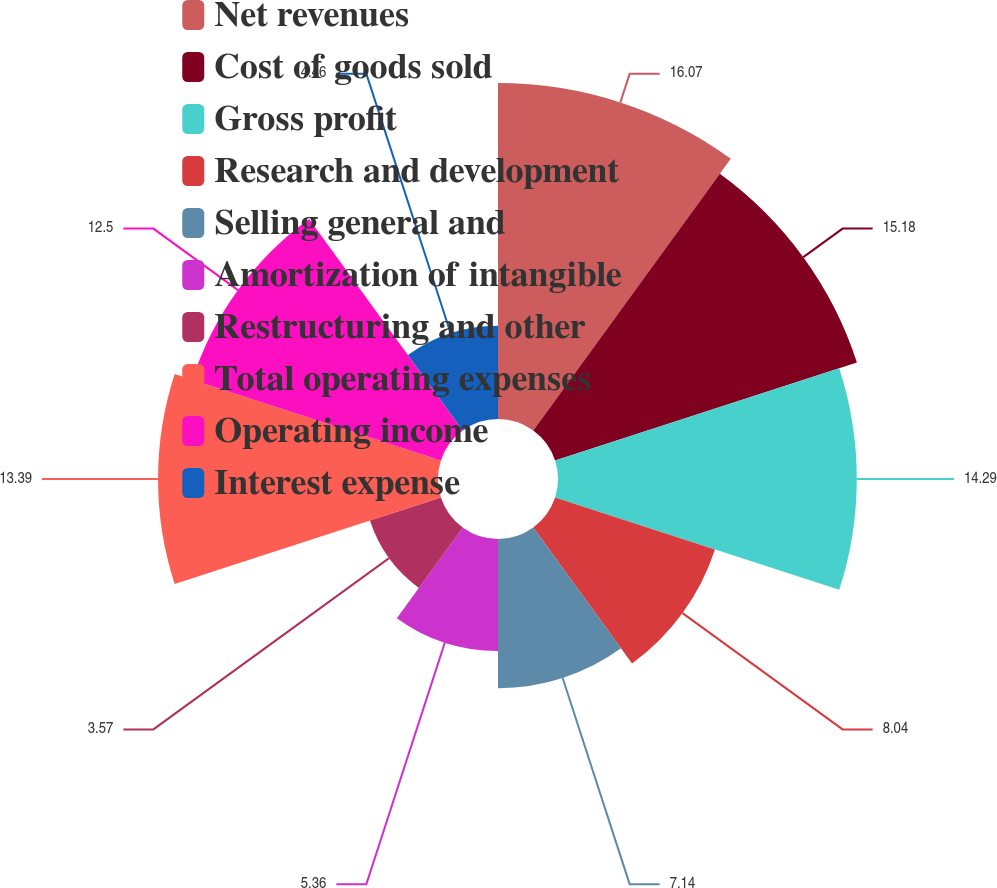Convert chart. <chart><loc_0><loc_0><loc_500><loc_500><pie_chart><fcel>Net revenues<fcel>Cost of goods sold<fcel>Gross profit<fcel>Research and development<fcel>Selling general and<fcel>Amortization of intangible<fcel>Restructuring and other<fcel>Total operating expenses<fcel>Operating income<fcel>Interest expense<nl><fcel>16.07%<fcel>15.18%<fcel>14.29%<fcel>8.04%<fcel>7.14%<fcel>5.36%<fcel>3.57%<fcel>13.39%<fcel>12.5%<fcel>4.46%<nl></chart> 